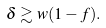Convert formula to latex. <formula><loc_0><loc_0><loc_500><loc_500>\delta \gtrsim w ( 1 - f ) .</formula> 